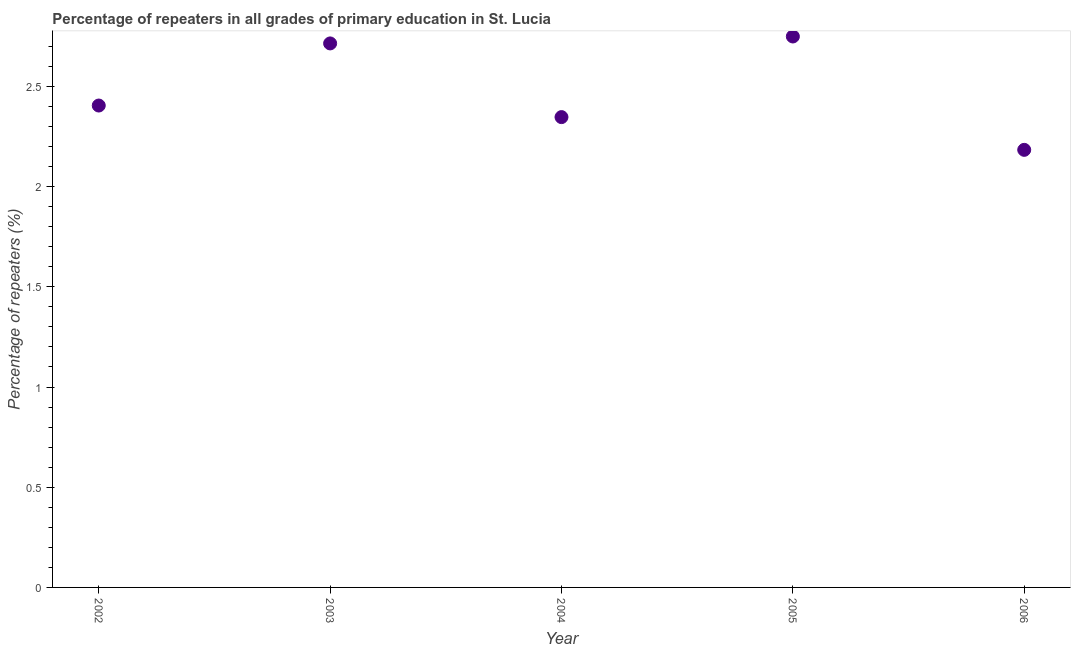What is the percentage of repeaters in primary education in 2003?
Offer a very short reply. 2.71. Across all years, what is the maximum percentage of repeaters in primary education?
Give a very brief answer. 2.75. Across all years, what is the minimum percentage of repeaters in primary education?
Offer a terse response. 2.18. In which year was the percentage of repeaters in primary education minimum?
Offer a very short reply. 2006. What is the sum of the percentage of repeaters in primary education?
Keep it short and to the point. 12.4. What is the difference between the percentage of repeaters in primary education in 2003 and 2006?
Your response must be concise. 0.53. What is the average percentage of repeaters in primary education per year?
Provide a succinct answer. 2.48. What is the median percentage of repeaters in primary education?
Keep it short and to the point. 2.4. In how many years, is the percentage of repeaters in primary education greater than 1 %?
Your answer should be compact. 5. What is the ratio of the percentage of repeaters in primary education in 2005 to that in 2006?
Provide a short and direct response. 1.26. Is the difference between the percentage of repeaters in primary education in 2004 and 2005 greater than the difference between any two years?
Give a very brief answer. No. What is the difference between the highest and the second highest percentage of repeaters in primary education?
Make the answer very short. 0.03. What is the difference between the highest and the lowest percentage of repeaters in primary education?
Your answer should be very brief. 0.57. How many years are there in the graph?
Make the answer very short. 5. Are the values on the major ticks of Y-axis written in scientific E-notation?
Offer a very short reply. No. What is the title of the graph?
Keep it short and to the point. Percentage of repeaters in all grades of primary education in St. Lucia. What is the label or title of the Y-axis?
Make the answer very short. Percentage of repeaters (%). What is the Percentage of repeaters (%) in 2002?
Offer a very short reply. 2.4. What is the Percentage of repeaters (%) in 2003?
Your response must be concise. 2.71. What is the Percentage of repeaters (%) in 2004?
Provide a succinct answer. 2.35. What is the Percentage of repeaters (%) in 2005?
Provide a succinct answer. 2.75. What is the Percentage of repeaters (%) in 2006?
Your answer should be very brief. 2.18. What is the difference between the Percentage of repeaters (%) in 2002 and 2003?
Make the answer very short. -0.31. What is the difference between the Percentage of repeaters (%) in 2002 and 2004?
Keep it short and to the point. 0.06. What is the difference between the Percentage of repeaters (%) in 2002 and 2005?
Provide a short and direct response. -0.34. What is the difference between the Percentage of repeaters (%) in 2002 and 2006?
Make the answer very short. 0.22. What is the difference between the Percentage of repeaters (%) in 2003 and 2004?
Offer a very short reply. 0.37. What is the difference between the Percentage of repeaters (%) in 2003 and 2005?
Offer a very short reply. -0.03. What is the difference between the Percentage of repeaters (%) in 2003 and 2006?
Ensure brevity in your answer.  0.53. What is the difference between the Percentage of repeaters (%) in 2004 and 2005?
Ensure brevity in your answer.  -0.4. What is the difference between the Percentage of repeaters (%) in 2004 and 2006?
Provide a short and direct response. 0.16. What is the difference between the Percentage of repeaters (%) in 2005 and 2006?
Give a very brief answer. 0.57. What is the ratio of the Percentage of repeaters (%) in 2002 to that in 2003?
Ensure brevity in your answer.  0.89. What is the ratio of the Percentage of repeaters (%) in 2002 to that in 2005?
Make the answer very short. 0.88. What is the ratio of the Percentage of repeaters (%) in 2002 to that in 2006?
Keep it short and to the point. 1.1. What is the ratio of the Percentage of repeaters (%) in 2003 to that in 2004?
Offer a terse response. 1.16. What is the ratio of the Percentage of repeaters (%) in 2003 to that in 2005?
Provide a short and direct response. 0.99. What is the ratio of the Percentage of repeaters (%) in 2003 to that in 2006?
Your response must be concise. 1.24. What is the ratio of the Percentage of repeaters (%) in 2004 to that in 2005?
Provide a short and direct response. 0.85. What is the ratio of the Percentage of repeaters (%) in 2004 to that in 2006?
Give a very brief answer. 1.07. What is the ratio of the Percentage of repeaters (%) in 2005 to that in 2006?
Keep it short and to the point. 1.26. 